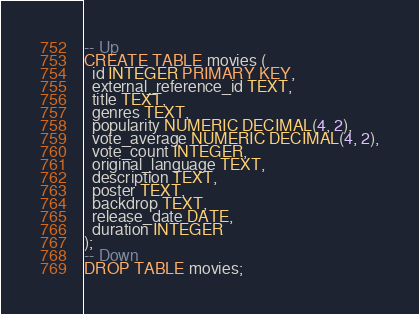<code> <loc_0><loc_0><loc_500><loc_500><_SQL_>-- Up
CREATE TABLE movies (
  id INTEGER PRIMARY KEY,
  external_reference_id TEXT,
  title TEXT,
  genres TEXT,
  popularity NUMERIC DECIMAL(4, 2),
  vote_average NUMERIC DECIMAL(4, 2),
  vote_count INTEGER,
  original_language TEXT,
  description TEXT,
  poster TEXT,
  backdrop TEXT,
  release_date DATE,
  duration INTEGER
);
-- Down
DROP TABLE movies;
</code> 